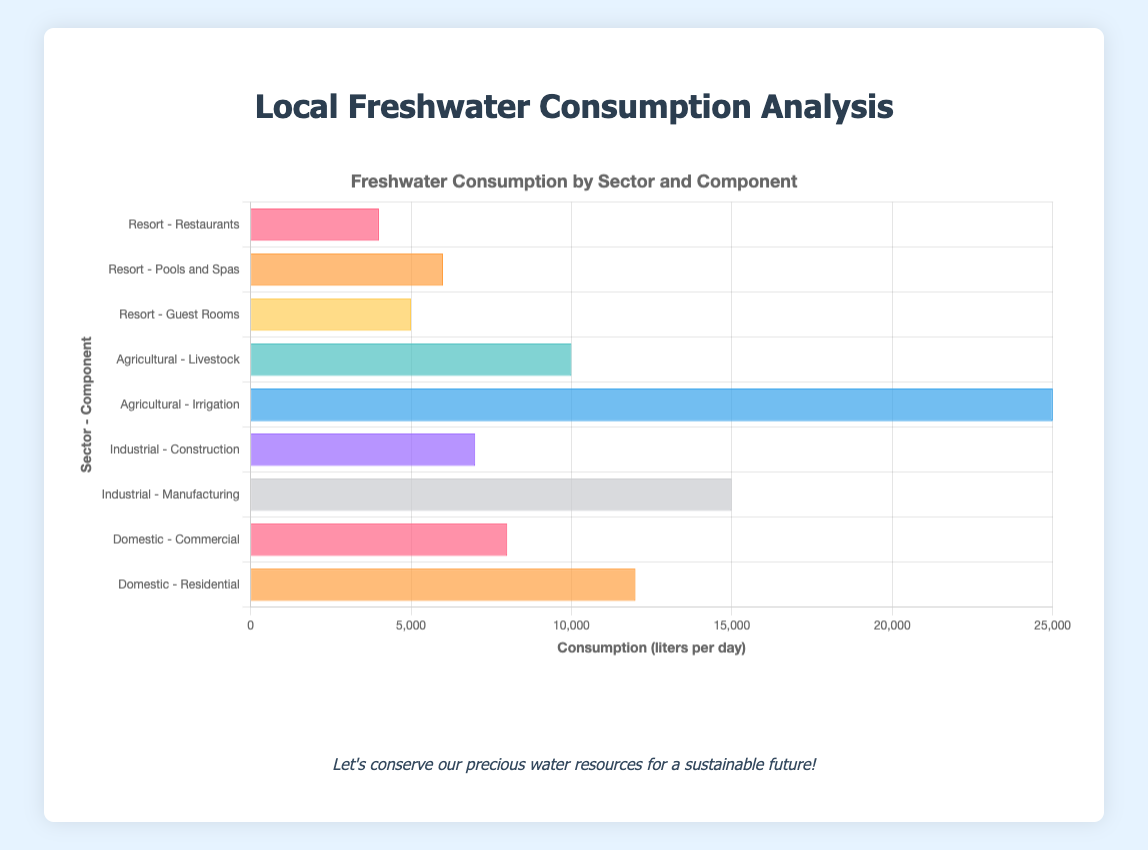What is the total freshwater consumption by the resort? The components listed for the resort are "Guest Rooms," "Pools and Spas," and "Restaurants." Summing up their consumptions: 5000 + 6000 + 4000 = 15000 liters per day.
Answer: 15000 liters per day Which sector has the highest freshwater consumption? The sectors shown are Domestic, Industrial, Agricultural, and Resort. By comparing their highest consumption components: Domestic (12000 liters), Industrial (15000 liters), Agricultural (25000 liters), and Resort (6000 liters), the highest figure is 25000 liters in the Agricultural sector.
Answer: Agricultural How much more freshwater is used in agriculture for irrigation than in industrial manufacturing? The consumption for agricultural irrigation is 25000 liters per day and for industrial manufacturing is 15000 liters per day. The difference is 25000 - 15000 = 10000 liters per day.
Answer: 10000 liters per day What is the combined freshwater consumption for domestic and industrial sectors? The components for the domestic sector are "Residential" (12000 liters) and "Commercial" (8000 liters). For the industrial sector, they are "Manufacturing" (15000 liters) and "Construction" (7000 liters). The total is 12000 + 8000 + 15000 + 7000 = 42000 liters per day.
Answer: 42000 liters per day Which component within the agricultural sector consumes less water than any component in the industrial sector? In the agricultural sector, the components are "Irrigation" (25000 liters) and "Livestock" (10000 liters). In the industrial sector, the components are "Manufacturing" (15000 liters) and "Construction" (7000 liters). The "Livestock" component (10000 liters) consumes less water than "Manufacturing" but not less than "Construction" (7000 liters).
Answer: None Which sector has the lowest overall freshwater consumption? By comparing the summed consumptions: Domestic (12000 + 8000 = 20000 liters), Industrial (15000 + 7000 = 22000 liters), Agricultural (25000 + 10000 = 35000 liters), and Resort (5000 + 6000 + 4000 = 15000 liters), the sector with the lowest consumption is the Resort.
Answer: Resort What percentage of total freshwater consumption is used by the Resort? First, find the total consumption by all sectors: 12000 + 8000 + 15000 + 7000 + 25000 + 10000 + 5000 + 6000 + 4000 = 87000 liters per day. The Resort's consumption is 15000 liters. The percentage is (15000 / 87000) * 100 ≈ 17.24%.
Answer: 17.24% Which sector uses more freshwater: domestic or industrial? By how much? Domestic sector uses 12000 + 8000 = 20000 liters per day, and Industrial sector uses 15000 + 7000 = 22000 liters per day. The Industrial sector uses 22000 - 20000 = 2000 liters more per day.
Answer: Industrial, 2000 liters per day 